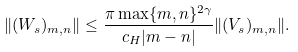<formula> <loc_0><loc_0><loc_500><loc_500>\| ( W _ { s } ) _ { m , n } \| \leq \frac { \pi \max \{ m , n \} ^ { 2 \gamma } } { c _ { H } | m - n | } \| ( V _ { s } ) _ { m , n } \| .</formula> 